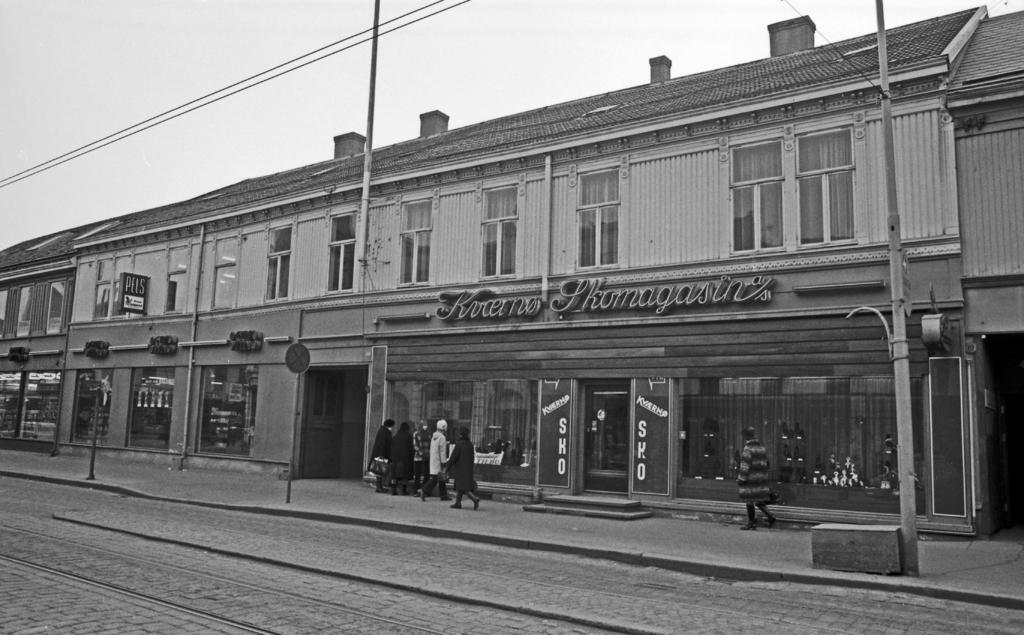In one or two sentences, can you explain what this image depicts? This is a black and white pic. At the bottom we can see road and poles. In the background we can see buildings, windows, hoardings on the wall, glass doors, few persons are walking and standing on the footpath. Through the glass doors we can see objects and at the top we can see electric wires and clouds in the sky. 